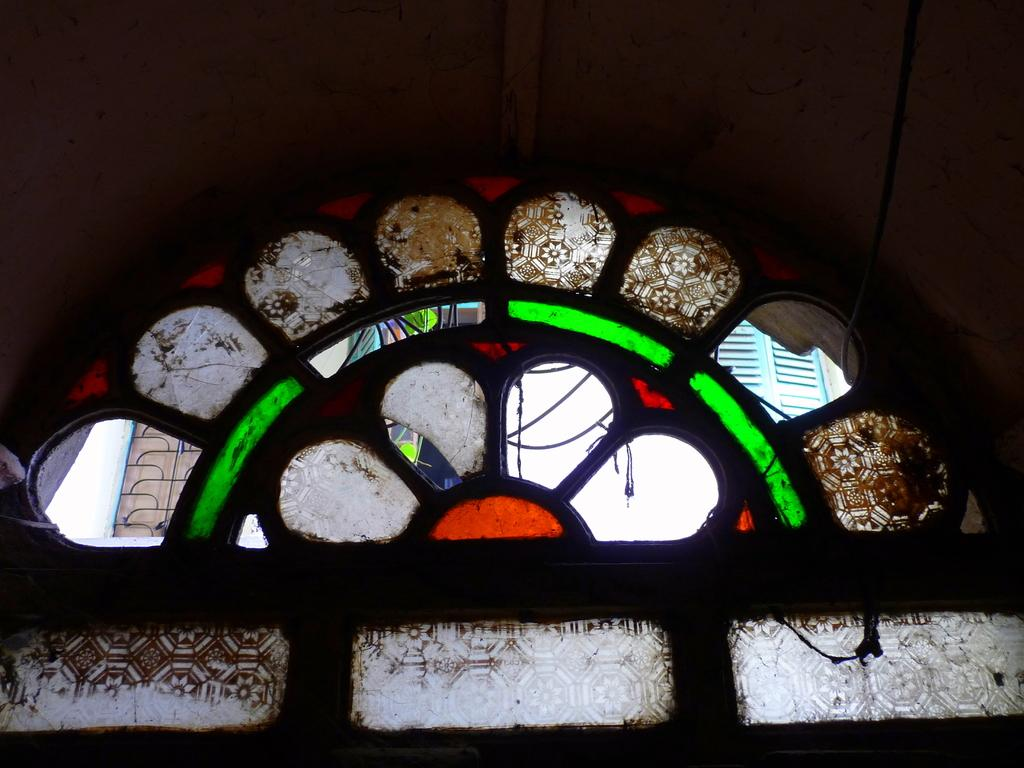What objects are in the center of the image? There are glasses in the center of the image. Can you describe the glasses in more detail? Unfortunately, the provided facts do not offer any additional details about the glasses. Are there any other objects or elements visible in the image? The given facts do not mention any other objects or elements in the image. What type of fan is placed on the sofa in the image? There is no fan or sofa present in the image; only glasses are mentioned. 